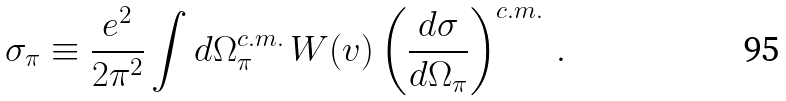<formula> <loc_0><loc_0><loc_500><loc_500>\sigma _ { \pi } \equiv \frac { e ^ { 2 } } { 2 \pi ^ { 2 } } \int d \Omega ^ { c . m . } _ { \pi } \, W ( v ) \left ( \frac { d \sigma } { d \Omega _ { \pi } } \right ) ^ { c . m . } \, .</formula> 